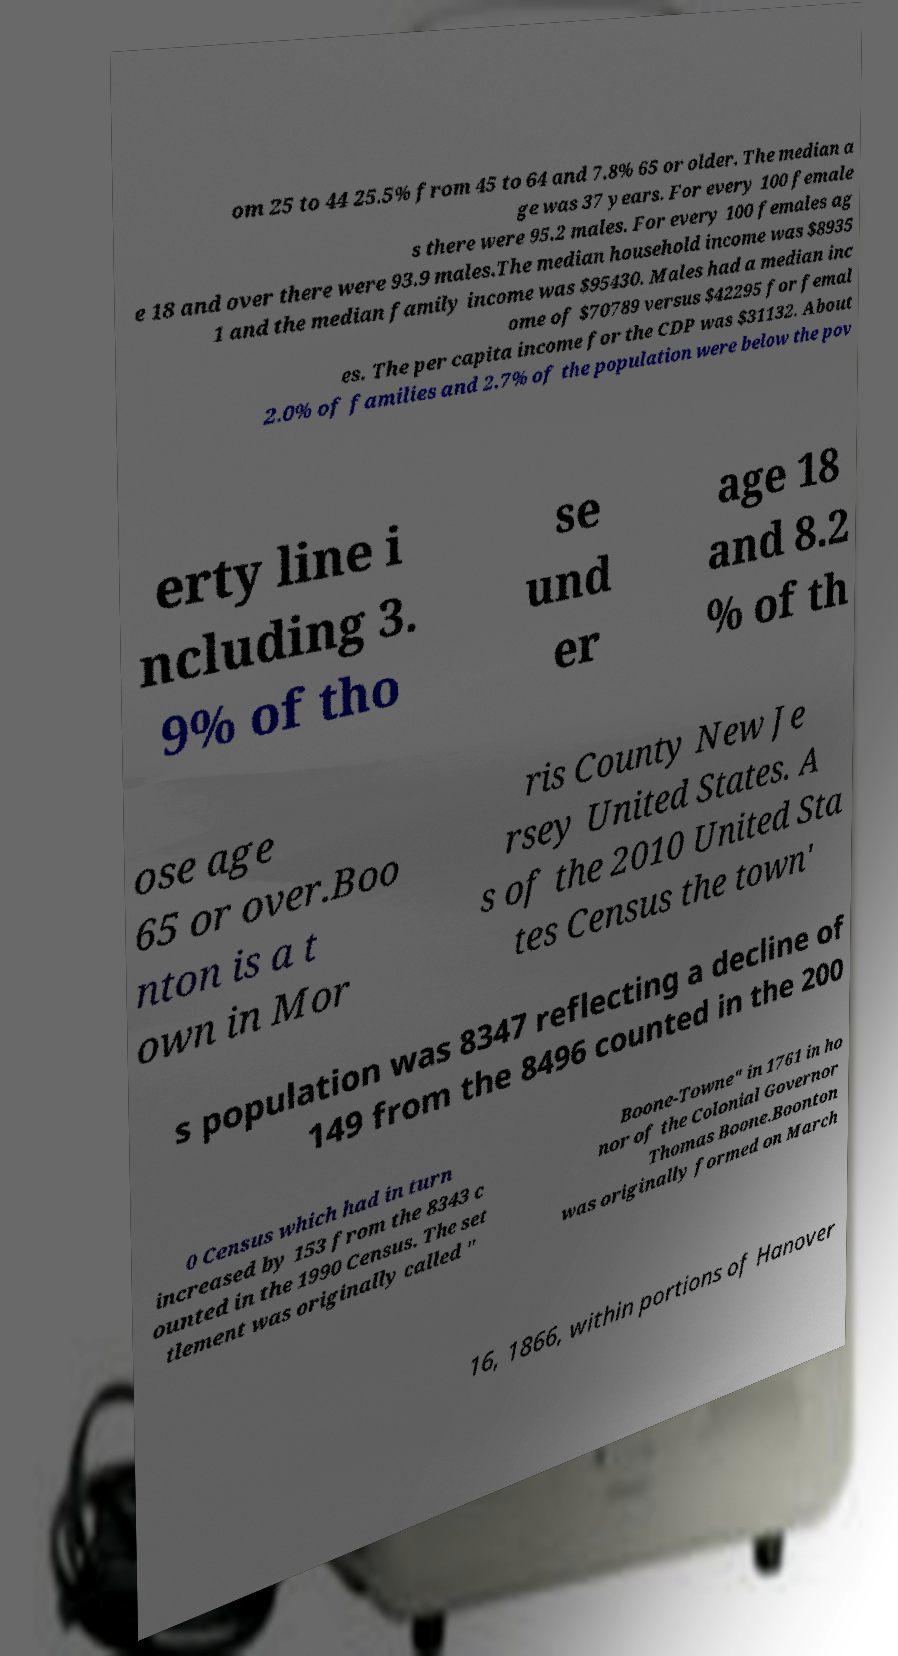I need the written content from this picture converted into text. Can you do that? om 25 to 44 25.5% from 45 to 64 and 7.8% 65 or older. The median a ge was 37 years. For every 100 female s there were 95.2 males. For every 100 females ag e 18 and over there were 93.9 males.The median household income was $8935 1 and the median family income was $95430. Males had a median inc ome of $70789 versus $42295 for femal es. The per capita income for the CDP was $31132. About 2.0% of families and 2.7% of the population were below the pov erty line i ncluding 3. 9% of tho se und er age 18 and 8.2 % of th ose age 65 or over.Boo nton is a t own in Mor ris County New Je rsey United States. A s of the 2010 United Sta tes Census the town' s population was 8347 reflecting a decline of 149 from the 8496 counted in the 200 0 Census which had in turn increased by 153 from the 8343 c ounted in the 1990 Census. The set tlement was originally called " Boone-Towne" in 1761 in ho nor of the Colonial Governor Thomas Boone.Boonton was originally formed on March 16, 1866, within portions of Hanover 